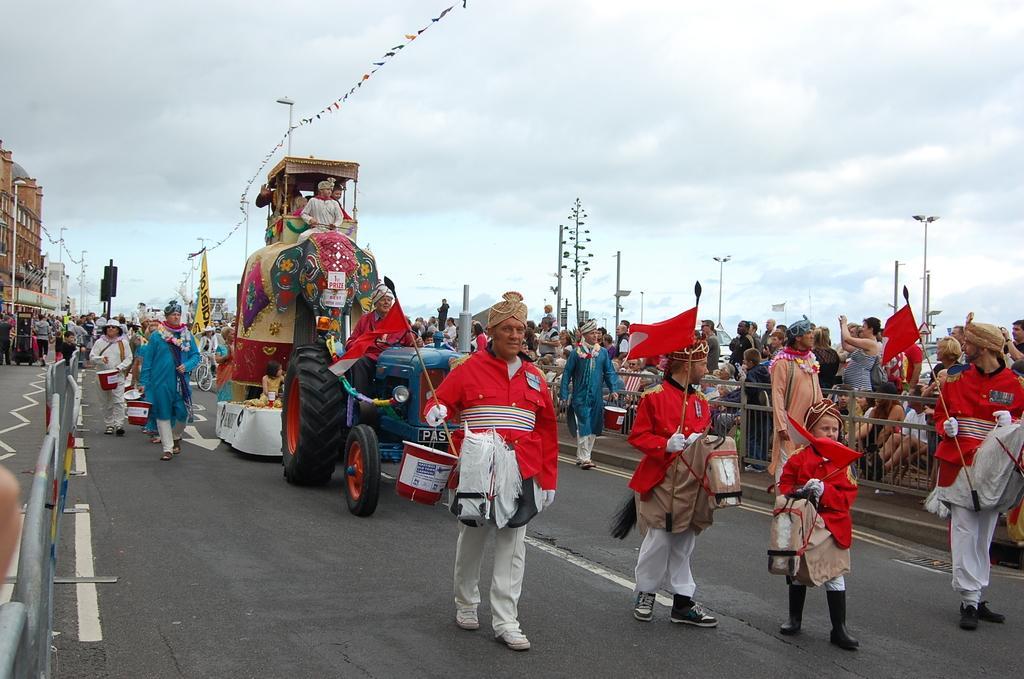Could you give a brief overview of what you see in this image? In this image we can see few persons are walking on the road by holding buckets and flags in their hands and few are riding on a vehicle. In the background there are few persons standing on the road and we can see fence, buildings, poles, hoardings, traffic signal poles and clouds in the sky. 